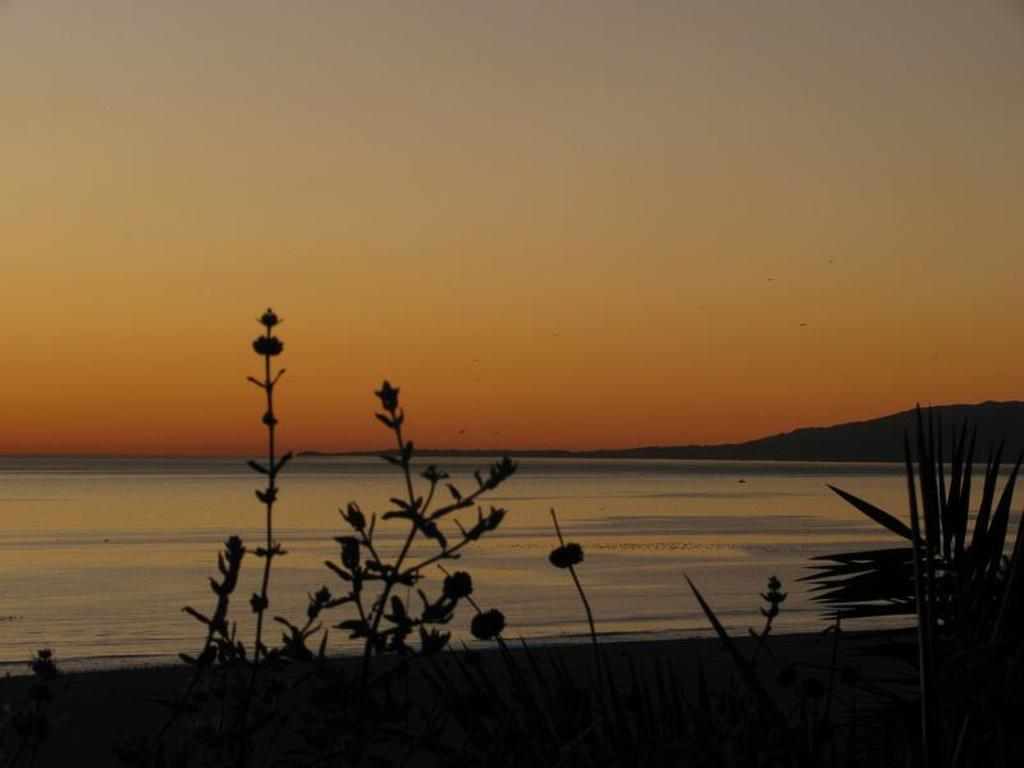What type of vegetation is present at the bottom of the image? There are plants at the bottom of the image. What natural element can be seen in the background of the image? There is water visible in the background of the image. What geographical feature is present in the background of the image? There is a mountain in the background of the image. What else is visible in the background of the image? The sky is visible in the background of the image. What arithmetic problem is being solved by the plants in the image? There is no arithmetic problem being solved by the plants in the image, as plants do not have the ability to perform arithmetic. What type of fiction is depicted in the image? There is no fiction depicted in the image; it features real-life elements such as plants, water, a mountain, and the sky. 